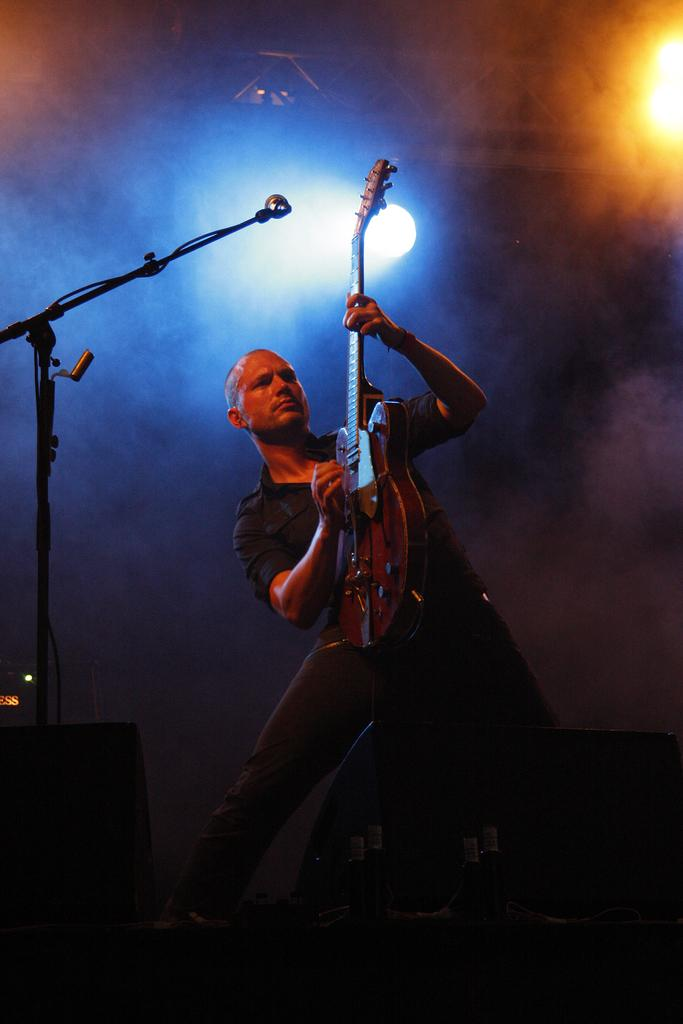What is the man in the image doing? The man is playing a guitar. Where is the mic stand located in the image? The mic stand is in the left corner of the image. What can be seen in the background of the image? There are lights visible in the background. What equipment is present on the stage in the image? There are speakers on the stage in the front of the image. What type of opinion can be heard from the market in the image? There is no market present in the image, and therefore no opinions can be heard. Can you tell me how many whistles are being blown in the image? There are no whistles being blown in the image. 